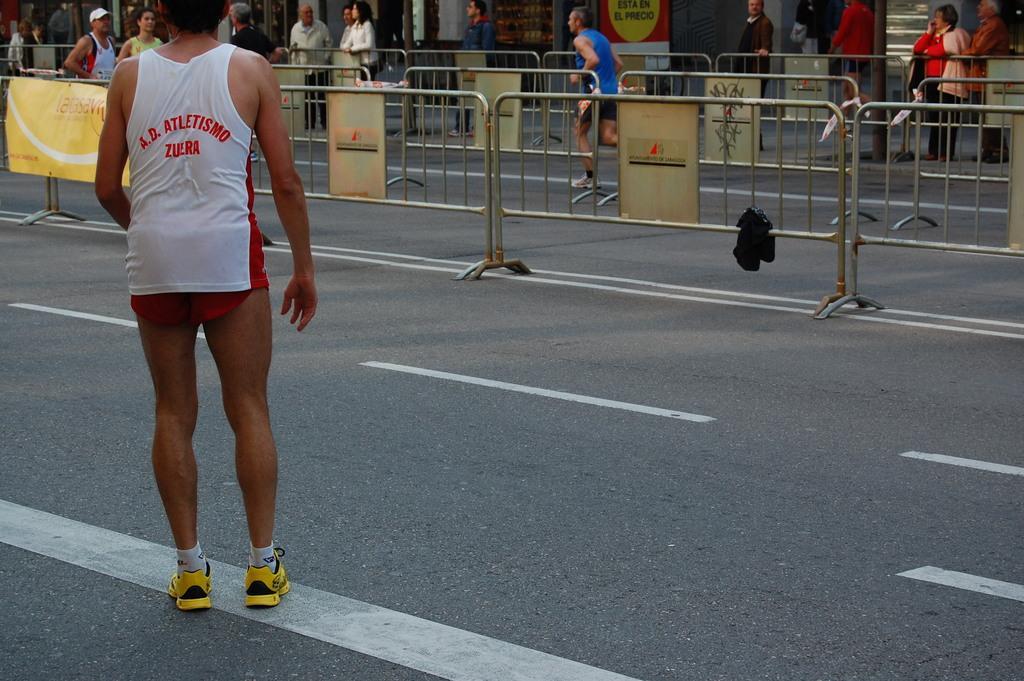In one or two sentences, can you explain what this image depicts? This is the picture of a road. In this picture there is a person standing on the road in the foreground. At the back there is a person with blue t-shirt is running and there are group of people standing behind the railing. There are posters on the railing. At the back there is a building. At the bottom there is a road. 